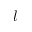<formula> <loc_0><loc_0><loc_500><loc_500>l</formula> 